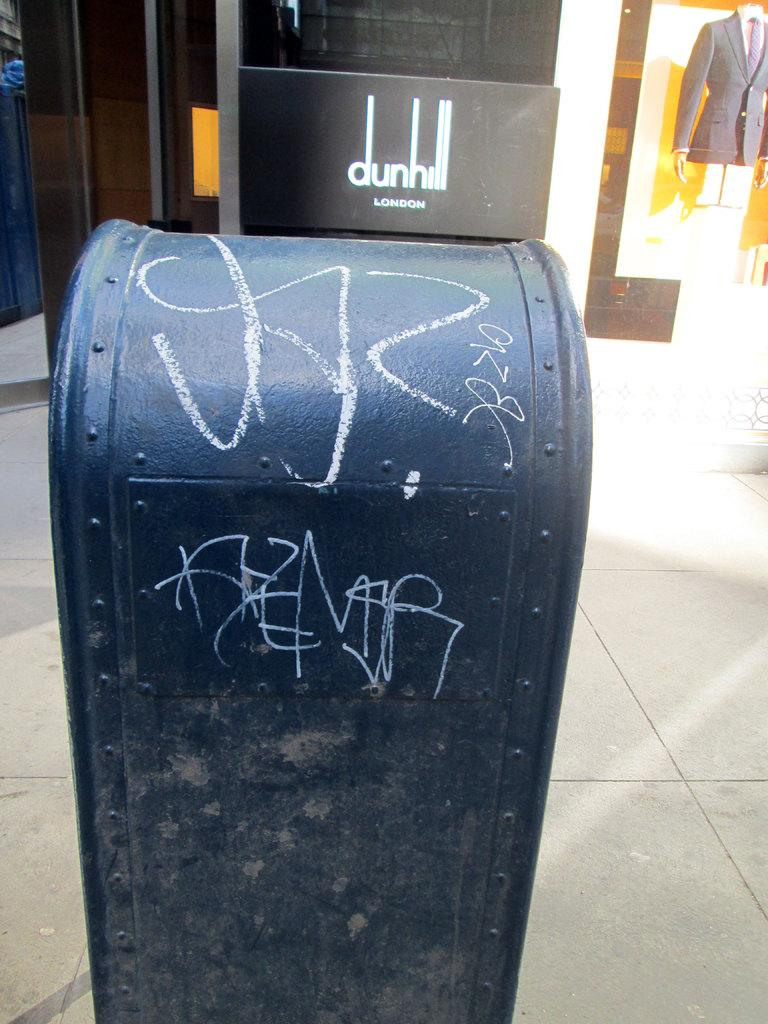<image>
Present a compact description of the photo's key features. A mailbox in front of the Dunhill in London has graffiti on it. 